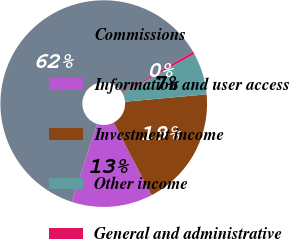Convert chart to OTSL. <chart><loc_0><loc_0><loc_500><loc_500><pie_chart><fcel>Commissions<fcel>Information and user access<fcel>Investment income<fcel>Other income<fcel>General and administrative<nl><fcel>61.64%<fcel>12.65%<fcel>18.78%<fcel>6.53%<fcel>0.41%<nl></chart> 